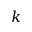<formula> <loc_0><loc_0><loc_500><loc_500>k</formula> 